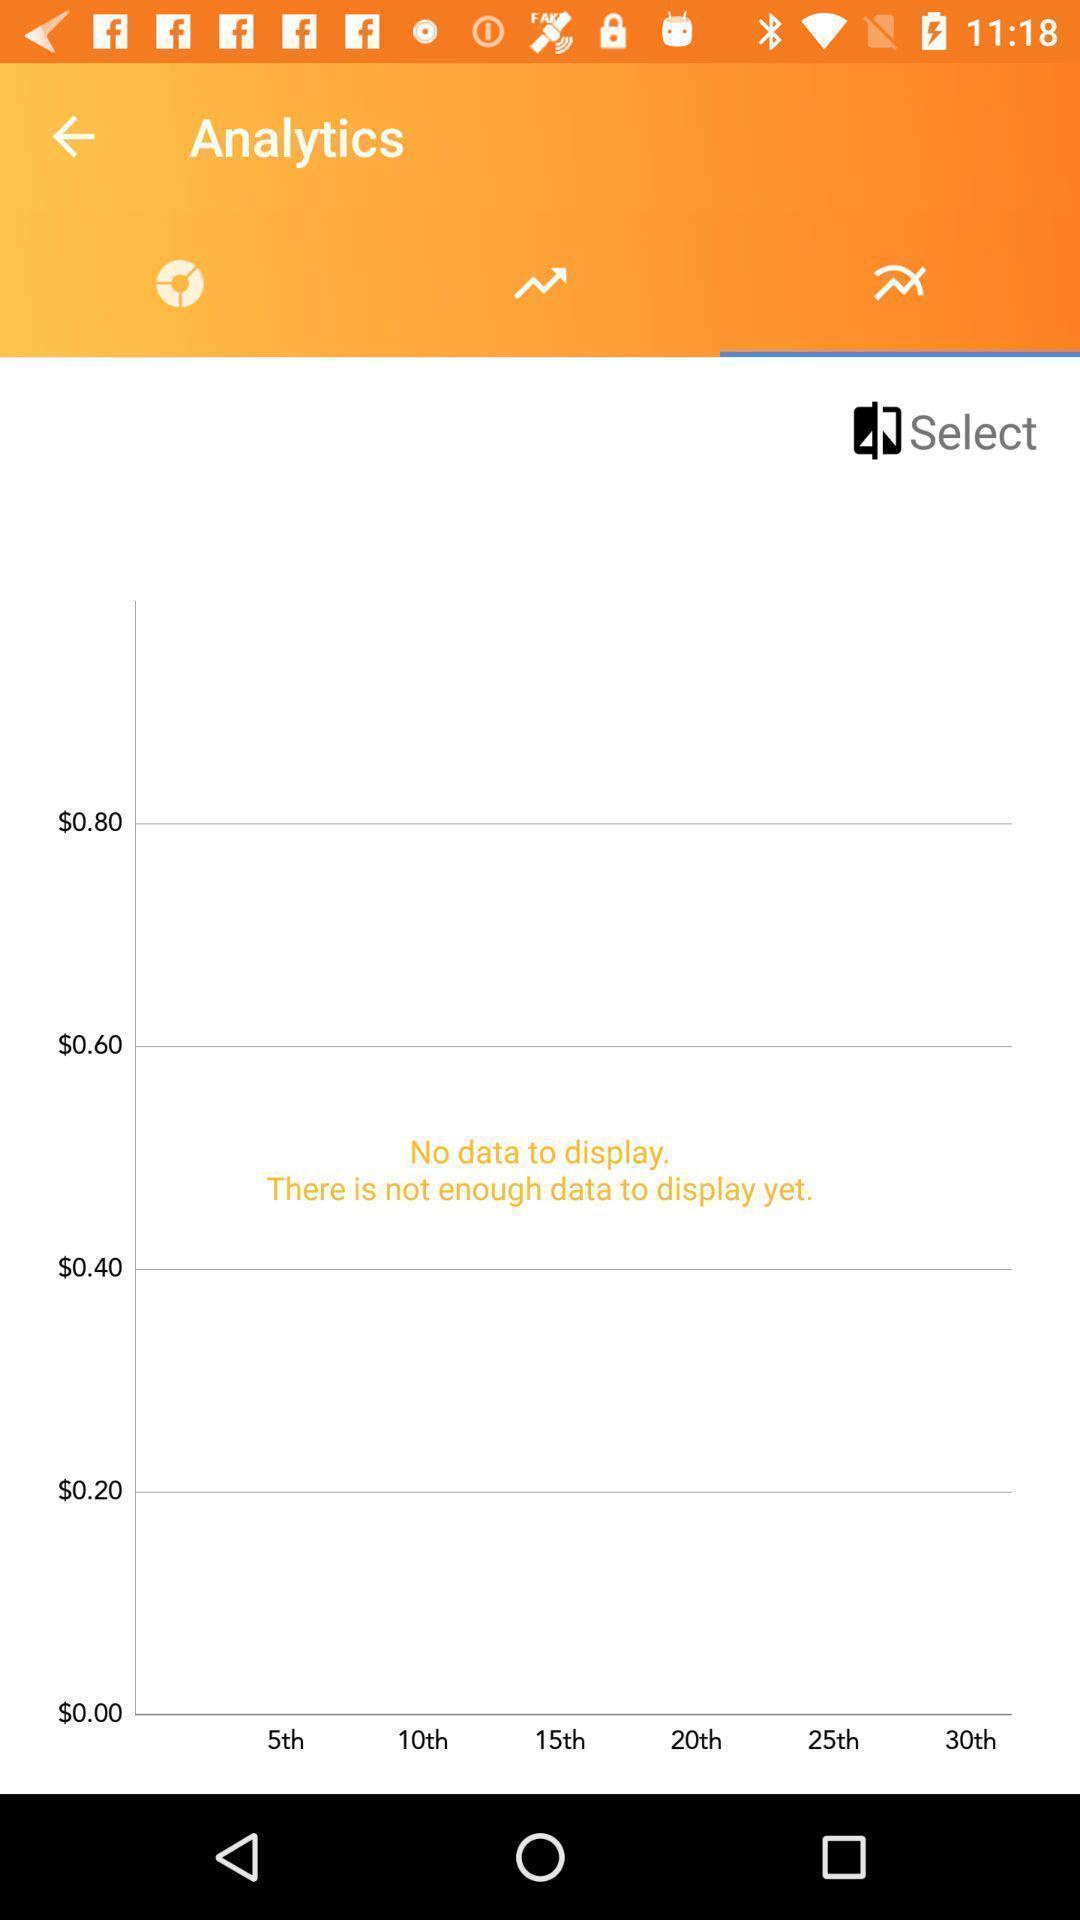Tell me about the visual elements in this screen capture. Page shows statistics of the payment app. 